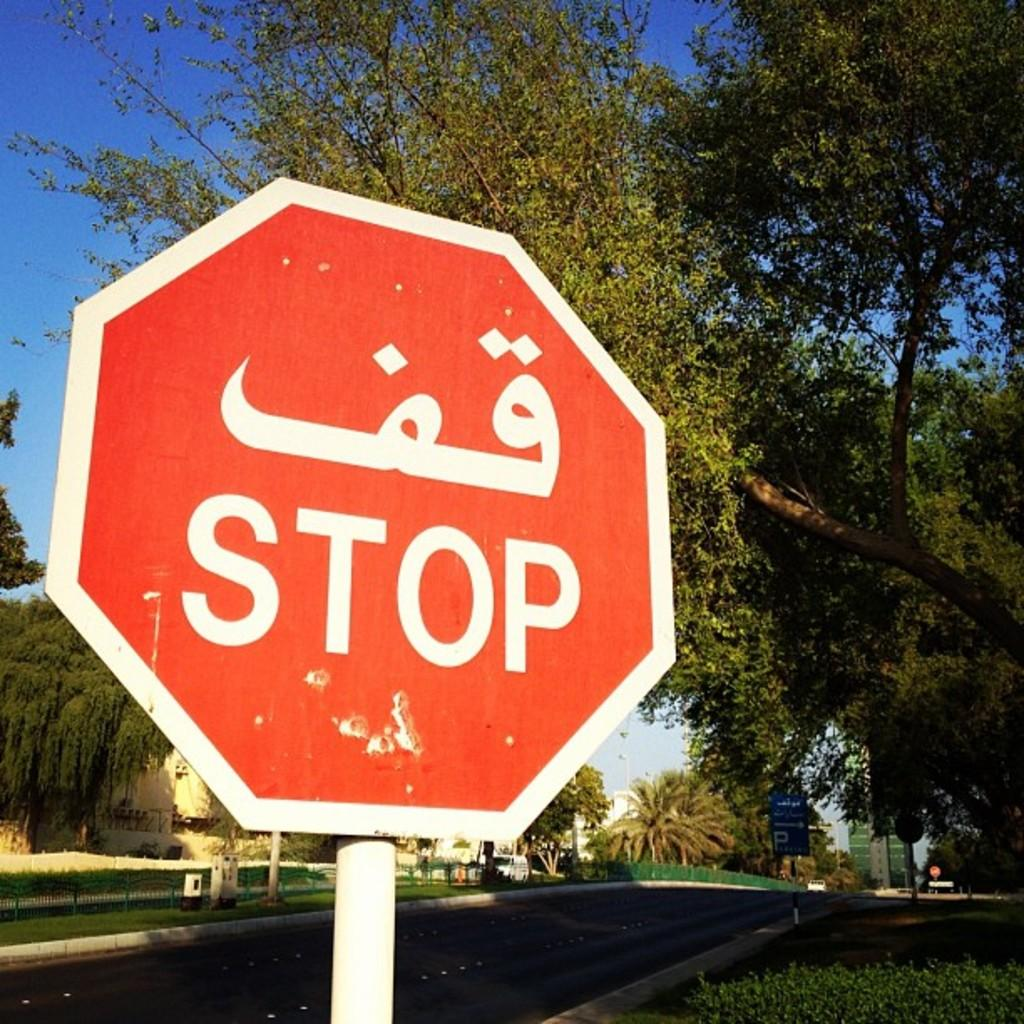<image>
Offer a succinct explanation of the picture presented. A red sign says stop in two different languages. 